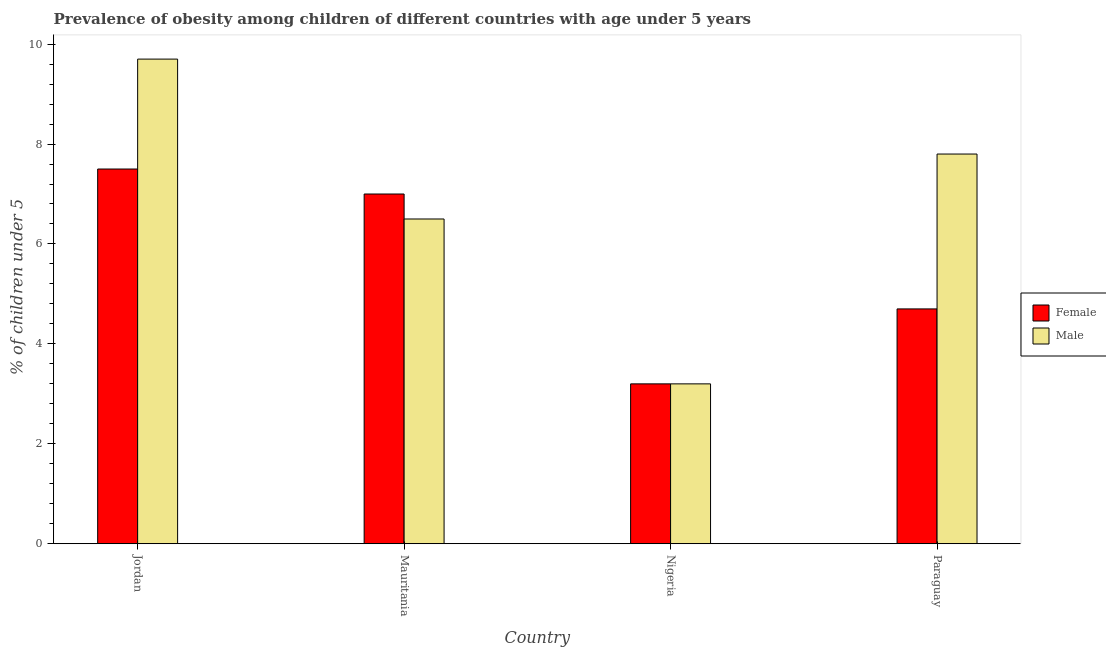How many groups of bars are there?
Keep it short and to the point. 4. Are the number of bars per tick equal to the number of legend labels?
Your answer should be compact. Yes. What is the label of the 2nd group of bars from the left?
Your answer should be compact. Mauritania. What is the percentage of obese male children in Nigeria?
Your response must be concise. 3.2. Across all countries, what is the maximum percentage of obese male children?
Give a very brief answer. 9.7. Across all countries, what is the minimum percentage of obese female children?
Keep it short and to the point. 3.2. In which country was the percentage of obese female children maximum?
Your response must be concise. Jordan. In which country was the percentage of obese female children minimum?
Your response must be concise. Nigeria. What is the total percentage of obese female children in the graph?
Give a very brief answer. 22.4. What is the difference between the percentage of obese female children in Nigeria and that in Paraguay?
Offer a very short reply. -1.5. What is the difference between the percentage of obese female children in Paraguay and the percentage of obese male children in Nigeria?
Keep it short and to the point. 1.5. What is the average percentage of obese male children per country?
Your answer should be very brief. 6.8. In how many countries, is the percentage of obese female children greater than 4.4 %?
Ensure brevity in your answer.  3. What is the ratio of the percentage of obese female children in Mauritania to that in Nigeria?
Your answer should be very brief. 2.19. Is the difference between the percentage of obese male children in Mauritania and Paraguay greater than the difference between the percentage of obese female children in Mauritania and Paraguay?
Provide a short and direct response. No. What is the difference between the highest and the second highest percentage of obese male children?
Keep it short and to the point. 1.9. What is the difference between the highest and the lowest percentage of obese female children?
Provide a short and direct response. 4.3. In how many countries, is the percentage of obese female children greater than the average percentage of obese female children taken over all countries?
Offer a very short reply. 2. How many countries are there in the graph?
Provide a short and direct response. 4. What is the difference between two consecutive major ticks on the Y-axis?
Give a very brief answer. 2. Are the values on the major ticks of Y-axis written in scientific E-notation?
Make the answer very short. No. Does the graph contain grids?
Make the answer very short. No. How are the legend labels stacked?
Provide a short and direct response. Vertical. What is the title of the graph?
Keep it short and to the point. Prevalence of obesity among children of different countries with age under 5 years. What is the label or title of the X-axis?
Your answer should be compact. Country. What is the label or title of the Y-axis?
Your answer should be compact.  % of children under 5. What is the  % of children under 5 of Male in Jordan?
Your response must be concise. 9.7. What is the  % of children under 5 in Female in Nigeria?
Make the answer very short. 3.2. What is the  % of children under 5 in Male in Nigeria?
Your answer should be very brief. 3.2. What is the  % of children under 5 in Female in Paraguay?
Offer a very short reply. 4.7. What is the  % of children under 5 of Male in Paraguay?
Provide a succinct answer. 7.8. Across all countries, what is the maximum  % of children under 5 in Male?
Your answer should be very brief. 9.7. Across all countries, what is the minimum  % of children under 5 of Female?
Offer a terse response. 3.2. Across all countries, what is the minimum  % of children under 5 in Male?
Provide a short and direct response. 3.2. What is the total  % of children under 5 of Female in the graph?
Your answer should be very brief. 22.4. What is the total  % of children under 5 of Male in the graph?
Make the answer very short. 27.2. What is the difference between the  % of children under 5 of Male in Jordan and that in Mauritania?
Provide a succinct answer. 3.2. What is the difference between the  % of children under 5 in Female in Jordan and that in Nigeria?
Provide a short and direct response. 4.3. What is the difference between the  % of children under 5 of Female in Mauritania and that in Nigeria?
Keep it short and to the point. 3.8. What is the difference between the  % of children under 5 in Male in Mauritania and that in Nigeria?
Your answer should be compact. 3.3. What is the difference between the  % of children under 5 in Female in Jordan and the  % of children under 5 in Male in Paraguay?
Your answer should be very brief. -0.3. What is the difference between the  % of children under 5 of Female in Mauritania and the  % of children under 5 of Male in Nigeria?
Ensure brevity in your answer.  3.8. What is the difference between the  % of children under 5 in Female in Mauritania and the  % of children under 5 in Male in Paraguay?
Offer a terse response. -0.8. What is the difference between the  % of children under 5 of Female in Nigeria and the  % of children under 5 of Male in Paraguay?
Give a very brief answer. -4.6. What is the difference between the  % of children under 5 of Female and  % of children under 5 of Male in Jordan?
Your answer should be compact. -2.2. What is the difference between the  % of children under 5 in Female and  % of children under 5 in Male in Mauritania?
Offer a very short reply. 0.5. What is the difference between the  % of children under 5 of Female and  % of children under 5 of Male in Nigeria?
Keep it short and to the point. 0. What is the difference between the  % of children under 5 in Female and  % of children under 5 in Male in Paraguay?
Your answer should be compact. -3.1. What is the ratio of the  % of children under 5 of Female in Jordan to that in Mauritania?
Your answer should be very brief. 1.07. What is the ratio of the  % of children under 5 of Male in Jordan to that in Mauritania?
Your answer should be very brief. 1.49. What is the ratio of the  % of children under 5 of Female in Jordan to that in Nigeria?
Give a very brief answer. 2.34. What is the ratio of the  % of children under 5 in Male in Jordan to that in Nigeria?
Provide a short and direct response. 3.03. What is the ratio of the  % of children under 5 of Female in Jordan to that in Paraguay?
Give a very brief answer. 1.6. What is the ratio of the  % of children under 5 in Male in Jordan to that in Paraguay?
Your answer should be compact. 1.24. What is the ratio of the  % of children under 5 of Female in Mauritania to that in Nigeria?
Your answer should be compact. 2.19. What is the ratio of the  % of children under 5 of Male in Mauritania to that in Nigeria?
Provide a succinct answer. 2.03. What is the ratio of the  % of children under 5 in Female in Mauritania to that in Paraguay?
Keep it short and to the point. 1.49. What is the ratio of the  % of children under 5 of Female in Nigeria to that in Paraguay?
Your answer should be very brief. 0.68. What is the ratio of the  % of children under 5 of Male in Nigeria to that in Paraguay?
Your answer should be very brief. 0.41. What is the difference between the highest and the second highest  % of children under 5 in Male?
Provide a succinct answer. 1.9. What is the difference between the highest and the lowest  % of children under 5 in Male?
Offer a terse response. 6.5. 